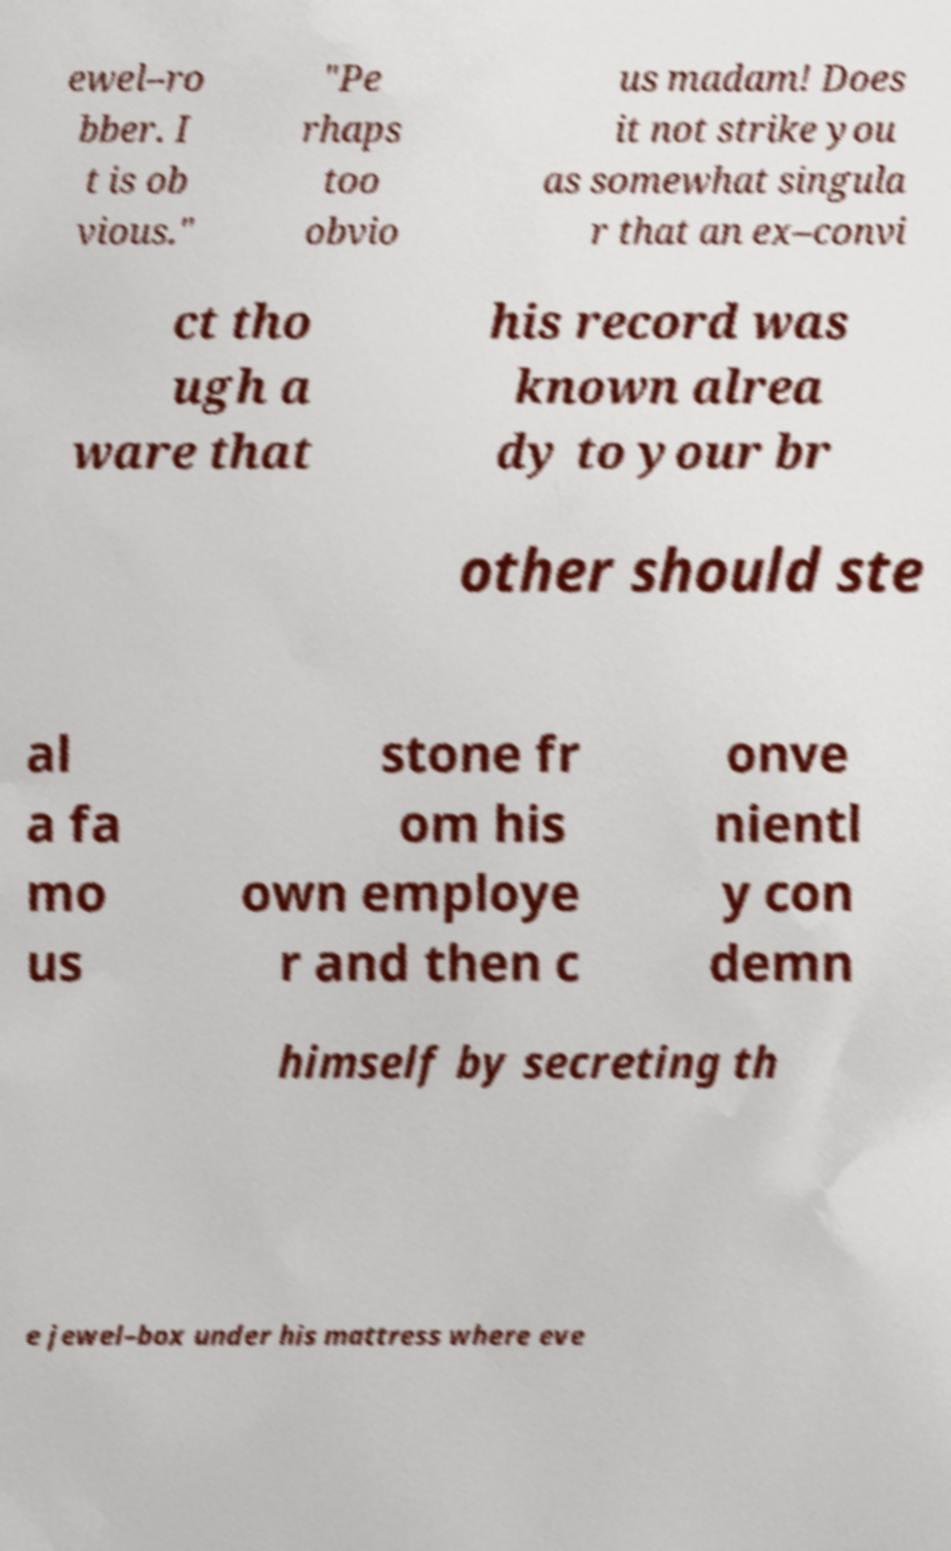Could you assist in decoding the text presented in this image and type it out clearly? ewel–ro bber. I t is ob vious." "Pe rhaps too obvio us madam! Does it not strike you as somewhat singula r that an ex–convi ct tho ugh a ware that his record was known alrea dy to your br other should ste al a fa mo us stone fr om his own employe r and then c onve nientl y con demn himself by secreting th e jewel–box under his mattress where eve 